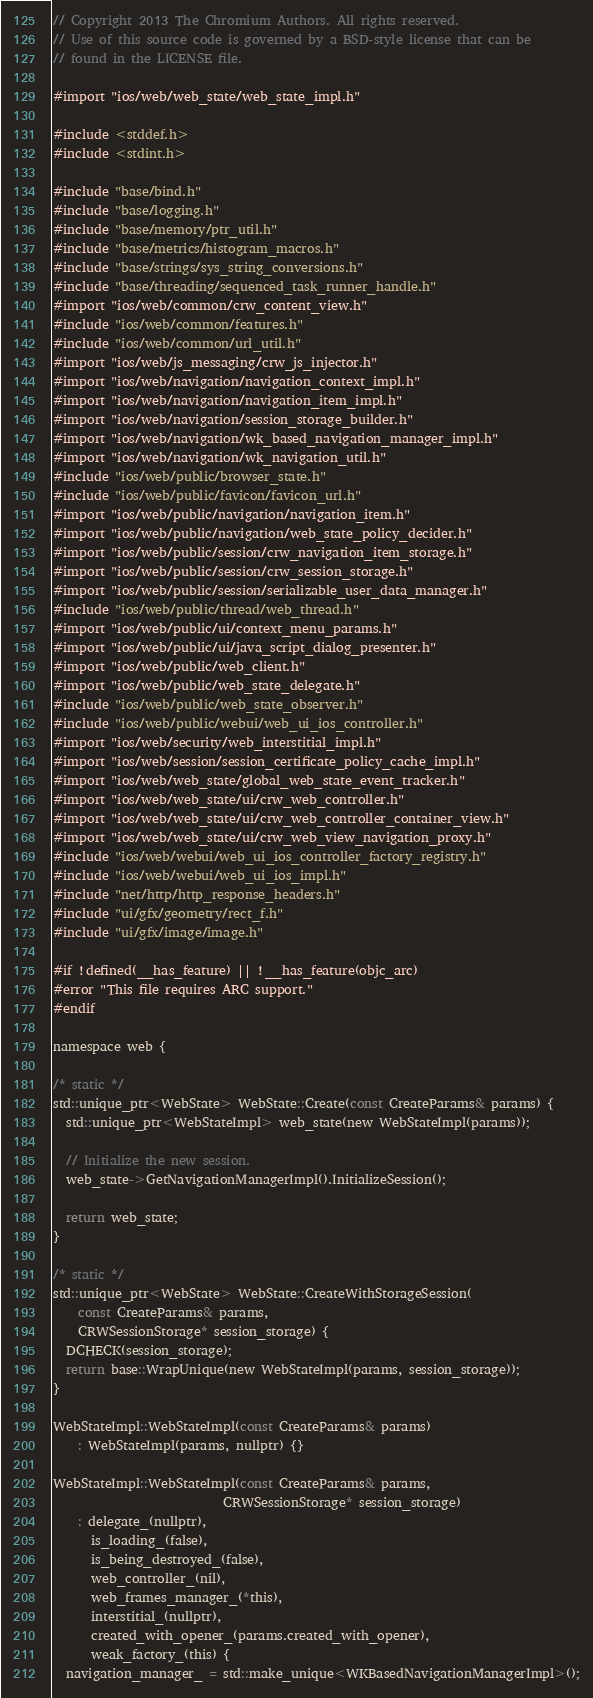Convert code to text. <code><loc_0><loc_0><loc_500><loc_500><_ObjectiveC_>// Copyright 2013 The Chromium Authors. All rights reserved.
// Use of this source code is governed by a BSD-style license that can be
// found in the LICENSE file.

#import "ios/web/web_state/web_state_impl.h"

#include <stddef.h>
#include <stdint.h>

#include "base/bind.h"
#include "base/logging.h"
#include "base/memory/ptr_util.h"
#include "base/metrics/histogram_macros.h"
#include "base/strings/sys_string_conversions.h"
#include "base/threading/sequenced_task_runner_handle.h"
#import "ios/web/common/crw_content_view.h"
#include "ios/web/common/features.h"
#include "ios/web/common/url_util.h"
#import "ios/web/js_messaging/crw_js_injector.h"
#import "ios/web/navigation/navigation_context_impl.h"
#import "ios/web/navigation/navigation_item_impl.h"
#import "ios/web/navigation/session_storage_builder.h"
#import "ios/web/navigation/wk_based_navigation_manager_impl.h"
#import "ios/web/navigation/wk_navigation_util.h"
#include "ios/web/public/browser_state.h"
#include "ios/web/public/favicon/favicon_url.h"
#import "ios/web/public/navigation/navigation_item.h"
#import "ios/web/public/navigation/web_state_policy_decider.h"
#import "ios/web/public/session/crw_navigation_item_storage.h"
#import "ios/web/public/session/crw_session_storage.h"
#import "ios/web/public/session/serializable_user_data_manager.h"
#include "ios/web/public/thread/web_thread.h"
#import "ios/web/public/ui/context_menu_params.h"
#import "ios/web/public/ui/java_script_dialog_presenter.h"
#import "ios/web/public/web_client.h"
#import "ios/web/public/web_state_delegate.h"
#include "ios/web/public/web_state_observer.h"
#include "ios/web/public/webui/web_ui_ios_controller.h"
#import "ios/web/security/web_interstitial_impl.h"
#import "ios/web/session/session_certificate_policy_cache_impl.h"
#import "ios/web/web_state/global_web_state_event_tracker.h"
#import "ios/web/web_state/ui/crw_web_controller.h"
#import "ios/web/web_state/ui/crw_web_controller_container_view.h"
#import "ios/web/web_state/ui/crw_web_view_navigation_proxy.h"
#include "ios/web/webui/web_ui_ios_controller_factory_registry.h"
#include "ios/web/webui/web_ui_ios_impl.h"
#include "net/http/http_response_headers.h"
#include "ui/gfx/geometry/rect_f.h"
#include "ui/gfx/image/image.h"

#if !defined(__has_feature) || !__has_feature(objc_arc)
#error "This file requires ARC support."
#endif

namespace web {

/* static */
std::unique_ptr<WebState> WebState::Create(const CreateParams& params) {
  std::unique_ptr<WebStateImpl> web_state(new WebStateImpl(params));

  // Initialize the new session.
  web_state->GetNavigationManagerImpl().InitializeSession();

  return web_state;
}

/* static */
std::unique_ptr<WebState> WebState::CreateWithStorageSession(
    const CreateParams& params,
    CRWSessionStorage* session_storage) {
  DCHECK(session_storage);
  return base::WrapUnique(new WebStateImpl(params, session_storage));
}

WebStateImpl::WebStateImpl(const CreateParams& params)
    : WebStateImpl(params, nullptr) {}

WebStateImpl::WebStateImpl(const CreateParams& params,
                           CRWSessionStorage* session_storage)
    : delegate_(nullptr),
      is_loading_(false),
      is_being_destroyed_(false),
      web_controller_(nil),
      web_frames_manager_(*this),
      interstitial_(nullptr),
      created_with_opener_(params.created_with_opener),
      weak_factory_(this) {
  navigation_manager_ = std::make_unique<WKBasedNavigationManagerImpl>();
</code> 